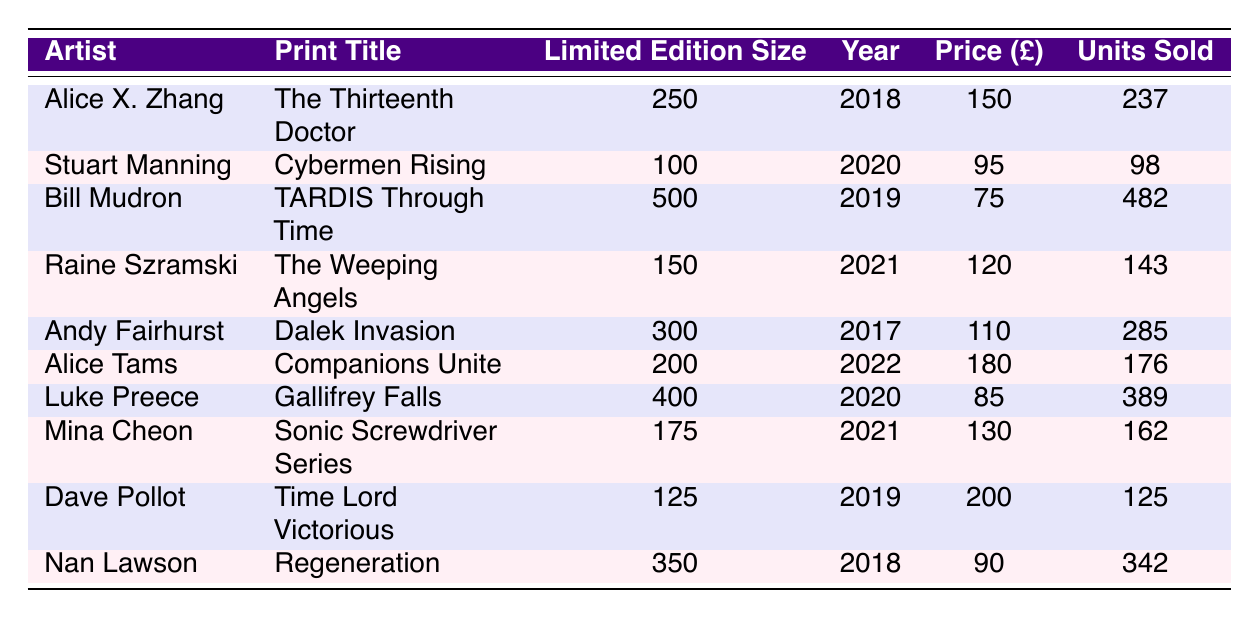What is the artist of the print titled "Dalek Invasion"? The table lists various prints and their respective artists. By looking for the print title "Dalek Invasion" in the table, I find that it is associated with the artist Andy Fairhurst.
Answer: Andy Fairhurst How many units of the print "TARDIS Through Time" were sold? The table shows that the print "TARDIS Through Time" sold 482 units, as indicated in the "Units Sold" column corresponding to that title.
Answer: 482 Which print had the highest number of units sold? I examine the "Units Sold" column and note that "TARDIS Through Time" has the highest value at 482.
Answer: TARDIS Through Time What is the average price of all prints listed? To calculate the average price, I first sum all the prices: 150 + 95 + 75 + 120 + 110 + 180 + 85 + 130 + 200 + 90 = 1,105. There are 10 prices, so the average is 1,105 divided by 10, which equals 110.5.
Answer: 110.5 Did Alice X. Zhang's print sell more units than Luke Preece's print? Alice X. Zhang's print "The Thirteenth Doctor" sold 237 units while Luke Preece's print "Gallifrey Falls" sold 389 units. Thus, 237 is less than 389, making the statement false.
Answer: No How many prints were sold for a price lower than £100? By checking the "Price (£)" column, I see that the prints priced at £95 (Cybermen Rising) and £75 (TARDIS Through Time) meet this criterion. Therefore, there are 2 prints that sold for less than £100.
Answer: 2 What is the total limited edition size of all prints combined? I sum the "Limited Edition Size" for all prints: 250 + 100 + 500 + 150 + 300 + 200 + 400 + 175 + 125 + 350 = 2250. This total represents the combined limited edition sizes of all prints.
Answer: 2250 Was the print "Companions Unite" released in a year later than "Cybermen Rising"? "Companions Unite" was released in 2022, while "Cybermen Rising" was released in 2020. Since 2022 is after 2020, the statement is true.
Answer: Yes How many prints sold more than 200 units? Looking at the "Units Sold" column, the prints with sales over 200 units are: "The Thirteenth Doctor" (237), "TARDIS Through Time" (482), "Dalek Invasion" (285), "Gallifrey Falls" (389), and "Regeneration" (342). There are 5 prints that sold more than 200 units.
Answer: 5 